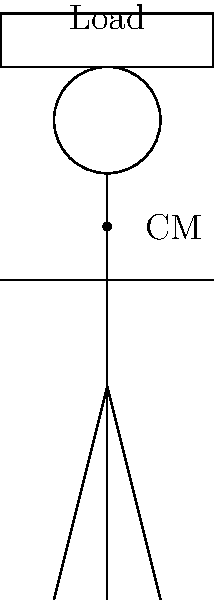When carrying a load on the head, as commonly practiced in Nigerian culture, what is the primary biomechanical advantage of this method in terms of energy expenditure? To understand the biomechanical advantage of carrying loads on the head, let's consider the following steps:

1. Center of Mass (CM): When a load is placed on the head, it aligns closely with the body's vertical axis, which passes through the center of mass.

2. Vertical Alignment: This alignment minimizes the horizontal displacement of the load from the body's CM.

3. Reduced Torque: By keeping the load close to the body's vertical axis, the torque (rotational force) on the spine and supporting muscles is minimized.

4. Stability: The vertical alignment promotes better balance and stability while walking.

5. Energy Efficiency: With reduced torque and improved stability, the body expends less energy to maintain posture and balance.

6. Muscle Activation: This method primarily engages the strong neck and back muscles, which are well-suited for supporting vertical loads.

7. Even Distribution: The weight is distributed evenly across the skull, reducing pressure points.

8. Hands-Free Advantage: This method leaves the hands free for other tasks or for balance.

The primary biomechanical advantage is that it minimizes energy expenditure by aligning the load closely with the body's center of mass, reducing torque on the spine and the need for constant postural adjustments.
Answer: Minimized energy expenditure due to load alignment with body's center of mass 